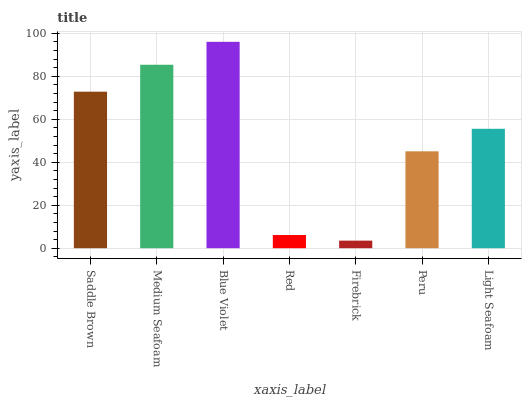Is Medium Seafoam the minimum?
Answer yes or no. No. Is Medium Seafoam the maximum?
Answer yes or no. No. Is Medium Seafoam greater than Saddle Brown?
Answer yes or no. Yes. Is Saddle Brown less than Medium Seafoam?
Answer yes or no. Yes. Is Saddle Brown greater than Medium Seafoam?
Answer yes or no. No. Is Medium Seafoam less than Saddle Brown?
Answer yes or no. No. Is Light Seafoam the high median?
Answer yes or no. Yes. Is Light Seafoam the low median?
Answer yes or no. Yes. Is Peru the high median?
Answer yes or no. No. Is Red the low median?
Answer yes or no. No. 